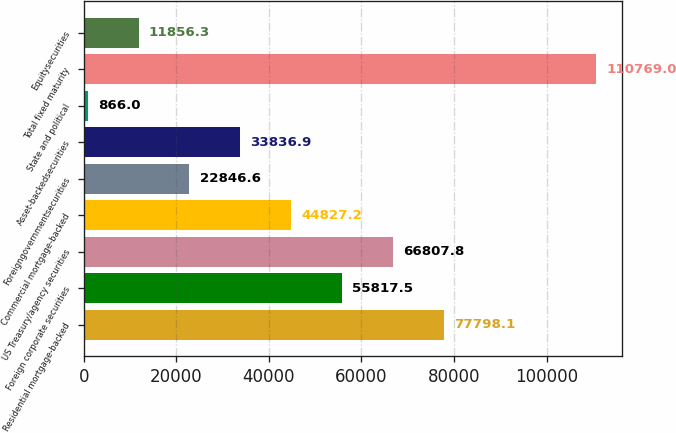Convert chart to OTSL. <chart><loc_0><loc_0><loc_500><loc_500><bar_chart><fcel>Residential mortgage-backed<fcel>Foreign corporate securities<fcel>US Treasury/agency securities<fcel>Commercial mortgage-backed<fcel>Foreigngovernmentsecurities<fcel>Asset-backedsecurities<fcel>State and political<fcel>Total fixed maturity<fcel>Equitysecurities<nl><fcel>77798.1<fcel>55817.5<fcel>66807.8<fcel>44827.2<fcel>22846.6<fcel>33836.9<fcel>866<fcel>110769<fcel>11856.3<nl></chart> 